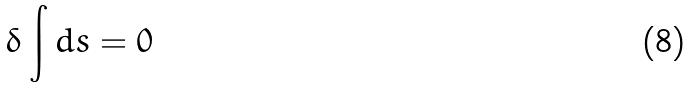Convert formula to latex. <formula><loc_0><loc_0><loc_500><loc_500>\delta \int d s = 0</formula> 